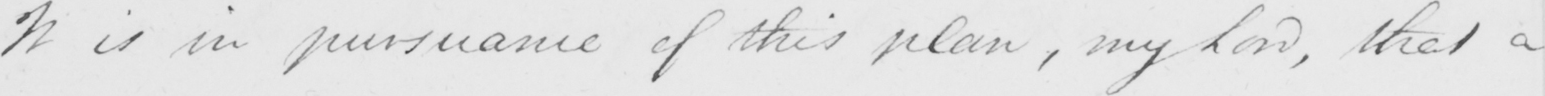What is written in this line of handwriting? It is in pursuance of this plan , my Lord , that a 